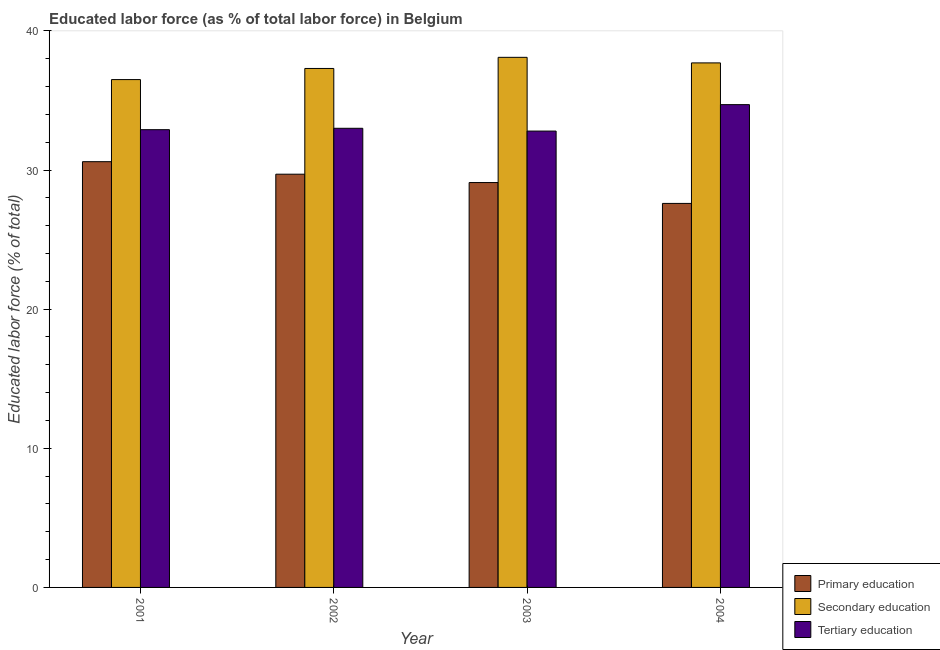How many different coloured bars are there?
Offer a terse response. 3. Are the number of bars per tick equal to the number of legend labels?
Your response must be concise. Yes. Are the number of bars on each tick of the X-axis equal?
Offer a terse response. Yes. How many bars are there on the 1st tick from the right?
Give a very brief answer. 3. What is the label of the 4th group of bars from the left?
Make the answer very short. 2004. In how many cases, is the number of bars for a given year not equal to the number of legend labels?
Offer a very short reply. 0. What is the percentage of labor force who received tertiary education in 2003?
Keep it short and to the point. 32.8. Across all years, what is the maximum percentage of labor force who received primary education?
Keep it short and to the point. 30.6. Across all years, what is the minimum percentage of labor force who received secondary education?
Your answer should be compact. 36.5. What is the total percentage of labor force who received tertiary education in the graph?
Give a very brief answer. 133.4. What is the difference between the percentage of labor force who received secondary education in 2003 and the percentage of labor force who received primary education in 2004?
Ensure brevity in your answer.  0.4. What is the average percentage of labor force who received secondary education per year?
Provide a short and direct response. 37.4. In the year 2003, what is the difference between the percentage of labor force who received tertiary education and percentage of labor force who received secondary education?
Provide a short and direct response. 0. What is the ratio of the percentage of labor force who received secondary education in 2002 to that in 2004?
Offer a very short reply. 0.99. What is the difference between the highest and the second highest percentage of labor force who received primary education?
Offer a terse response. 0.9. What is the difference between the highest and the lowest percentage of labor force who received tertiary education?
Offer a terse response. 1.9. In how many years, is the percentage of labor force who received secondary education greater than the average percentage of labor force who received secondary education taken over all years?
Your response must be concise. 2. What does the 2nd bar from the left in 2001 represents?
Keep it short and to the point. Secondary education. What does the 1st bar from the right in 2003 represents?
Keep it short and to the point. Tertiary education. Is it the case that in every year, the sum of the percentage of labor force who received primary education and percentage of labor force who received secondary education is greater than the percentage of labor force who received tertiary education?
Offer a terse response. Yes. How many bars are there?
Make the answer very short. 12. How many years are there in the graph?
Provide a succinct answer. 4. What is the difference between two consecutive major ticks on the Y-axis?
Your answer should be compact. 10. Does the graph contain any zero values?
Offer a very short reply. No. Does the graph contain grids?
Keep it short and to the point. No. How many legend labels are there?
Provide a succinct answer. 3. How are the legend labels stacked?
Offer a terse response. Vertical. What is the title of the graph?
Provide a short and direct response. Educated labor force (as % of total labor force) in Belgium. What is the label or title of the Y-axis?
Ensure brevity in your answer.  Educated labor force (% of total). What is the Educated labor force (% of total) of Primary education in 2001?
Keep it short and to the point. 30.6. What is the Educated labor force (% of total) in Secondary education in 2001?
Offer a very short reply. 36.5. What is the Educated labor force (% of total) in Tertiary education in 2001?
Your response must be concise. 32.9. What is the Educated labor force (% of total) in Primary education in 2002?
Your answer should be very brief. 29.7. What is the Educated labor force (% of total) in Secondary education in 2002?
Your response must be concise. 37.3. What is the Educated labor force (% of total) of Primary education in 2003?
Your answer should be compact. 29.1. What is the Educated labor force (% of total) in Secondary education in 2003?
Provide a succinct answer. 38.1. What is the Educated labor force (% of total) of Tertiary education in 2003?
Make the answer very short. 32.8. What is the Educated labor force (% of total) of Primary education in 2004?
Offer a very short reply. 27.6. What is the Educated labor force (% of total) in Secondary education in 2004?
Provide a succinct answer. 37.7. What is the Educated labor force (% of total) of Tertiary education in 2004?
Make the answer very short. 34.7. Across all years, what is the maximum Educated labor force (% of total) of Primary education?
Your response must be concise. 30.6. Across all years, what is the maximum Educated labor force (% of total) in Secondary education?
Provide a succinct answer. 38.1. Across all years, what is the maximum Educated labor force (% of total) in Tertiary education?
Provide a succinct answer. 34.7. Across all years, what is the minimum Educated labor force (% of total) in Primary education?
Keep it short and to the point. 27.6. Across all years, what is the minimum Educated labor force (% of total) in Secondary education?
Make the answer very short. 36.5. Across all years, what is the minimum Educated labor force (% of total) of Tertiary education?
Offer a terse response. 32.8. What is the total Educated labor force (% of total) of Primary education in the graph?
Make the answer very short. 117. What is the total Educated labor force (% of total) of Secondary education in the graph?
Provide a succinct answer. 149.6. What is the total Educated labor force (% of total) of Tertiary education in the graph?
Make the answer very short. 133.4. What is the difference between the Educated labor force (% of total) in Primary education in 2001 and that in 2002?
Your response must be concise. 0.9. What is the difference between the Educated labor force (% of total) of Tertiary education in 2001 and that in 2002?
Offer a very short reply. -0.1. What is the difference between the Educated labor force (% of total) of Secondary education in 2001 and that in 2004?
Offer a terse response. -1.2. What is the difference between the Educated labor force (% of total) of Tertiary education in 2001 and that in 2004?
Provide a succinct answer. -1.8. What is the difference between the Educated labor force (% of total) in Primary education in 2002 and that in 2003?
Your answer should be compact. 0.6. What is the difference between the Educated labor force (% of total) of Secondary education in 2002 and that in 2004?
Offer a terse response. -0.4. What is the difference between the Educated labor force (% of total) in Primary education in 2003 and that in 2004?
Your answer should be compact. 1.5. What is the difference between the Educated labor force (% of total) in Secondary education in 2001 and the Educated labor force (% of total) in Tertiary education in 2002?
Make the answer very short. 3.5. What is the difference between the Educated labor force (% of total) in Primary education in 2001 and the Educated labor force (% of total) in Secondary education in 2003?
Make the answer very short. -7.5. What is the difference between the Educated labor force (% of total) of Primary education in 2001 and the Educated labor force (% of total) of Tertiary education in 2003?
Offer a terse response. -2.2. What is the difference between the Educated labor force (% of total) in Secondary education in 2001 and the Educated labor force (% of total) in Tertiary education in 2003?
Your answer should be compact. 3.7. What is the difference between the Educated labor force (% of total) in Primary education in 2001 and the Educated labor force (% of total) in Secondary education in 2004?
Your answer should be very brief. -7.1. What is the difference between the Educated labor force (% of total) in Primary education in 2002 and the Educated labor force (% of total) in Secondary education in 2003?
Make the answer very short. -8.4. What is the difference between the Educated labor force (% of total) of Primary education in 2002 and the Educated labor force (% of total) of Tertiary education in 2003?
Give a very brief answer. -3.1. What is the difference between the Educated labor force (% of total) in Secondary education in 2002 and the Educated labor force (% of total) in Tertiary education in 2003?
Provide a short and direct response. 4.5. What is the difference between the Educated labor force (% of total) of Primary education in 2002 and the Educated labor force (% of total) of Secondary education in 2004?
Give a very brief answer. -8. What is the difference between the Educated labor force (% of total) in Secondary education in 2002 and the Educated labor force (% of total) in Tertiary education in 2004?
Offer a very short reply. 2.6. What is the difference between the Educated labor force (% of total) in Primary education in 2003 and the Educated labor force (% of total) in Secondary education in 2004?
Offer a very short reply. -8.6. What is the difference between the Educated labor force (% of total) in Primary education in 2003 and the Educated labor force (% of total) in Tertiary education in 2004?
Offer a very short reply. -5.6. What is the average Educated labor force (% of total) in Primary education per year?
Your answer should be compact. 29.25. What is the average Educated labor force (% of total) in Secondary education per year?
Make the answer very short. 37.4. What is the average Educated labor force (% of total) in Tertiary education per year?
Make the answer very short. 33.35. In the year 2001, what is the difference between the Educated labor force (% of total) of Primary education and Educated labor force (% of total) of Tertiary education?
Provide a short and direct response. -2.3. In the year 2002, what is the difference between the Educated labor force (% of total) in Primary education and Educated labor force (% of total) in Secondary education?
Provide a succinct answer. -7.6. In the year 2003, what is the difference between the Educated labor force (% of total) in Secondary education and Educated labor force (% of total) in Tertiary education?
Offer a very short reply. 5.3. In the year 2004, what is the difference between the Educated labor force (% of total) of Primary education and Educated labor force (% of total) of Tertiary education?
Keep it short and to the point. -7.1. What is the ratio of the Educated labor force (% of total) of Primary education in 2001 to that in 2002?
Offer a terse response. 1.03. What is the ratio of the Educated labor force (% of total) of Secondary education in 2001 to that in 2002?
Give a very brief answer. 0.98. What is the ratio of the Educated labor force (% of total) of Tertiary education in 2001 to that in 2002?
Provide a short and direct response. 1. What is the ratio of the Educated labor force (% of total) in Primary education in 2001 to that in 2003?
Offer a terse response. 1.05. What is the ratio of the Educated labor force (% of total) of Secondary education in 2001 to that in 2003?
Make the answer very short. 0.96. What is the ratio of the Educated labor force (% of total) in Primary education in 2001 to that in 2004?
Your answer should be compact. 1.11. What is the ratio of the Educated labor force (% of total) of Secondary education in 2001 to that in 2004?
Provide a succinct answer. 0.97. What is the ratio of the Educated labor force (% of total) of Tertiary education in 2001 to that in 2004?
Give a very brief answer. 0.95. What is the ratio of the Educated labor force (% of total) of Primary education in 2002 to that in 2003?
Keep it short and to the point. 1.02. What is the ratio of the Educated labor force (% of total) of Secondary education in 2002 to that in 2003?
Offer a very short reply. 0.98. What is the ratio of the Educated labor force (% of total) of Tertiary education in 2002 to that in 2003?
Keep it short and to the point. 1.01. What is the ratio of the Educated labor force (% of total) of Primary education in 2002 to that in 2004?
Provide a short and direct response. 1.08. What is the ratio of the Educated labor force (% of total) of Tertiary education in 2002 to that in 2004?
Your response must be concise. 0.95. What is the ratio of the Educated labor force (% of total) in Primary education in 2003 to that in 2004?
Offer a very short reply. 1.05. What is the ratio of the Educated labor force (% of total) of Secondary education in 2003 to that in 2004?
Make the answer very short. 1.01. What is the ratio of the Educated labor force (% of total) in Tertiary education in 2003 to that in 2004?
Provide a short and direct response. 0.95. What is the difference between the highest and the second highest Educated labor force (% of total) of Primary education?
Your response must be concise. 0.9. What is the difference between the highest and the lowest Educated labor force (% of total) of Tertiary education?
Your response must be concise. 1.9. 